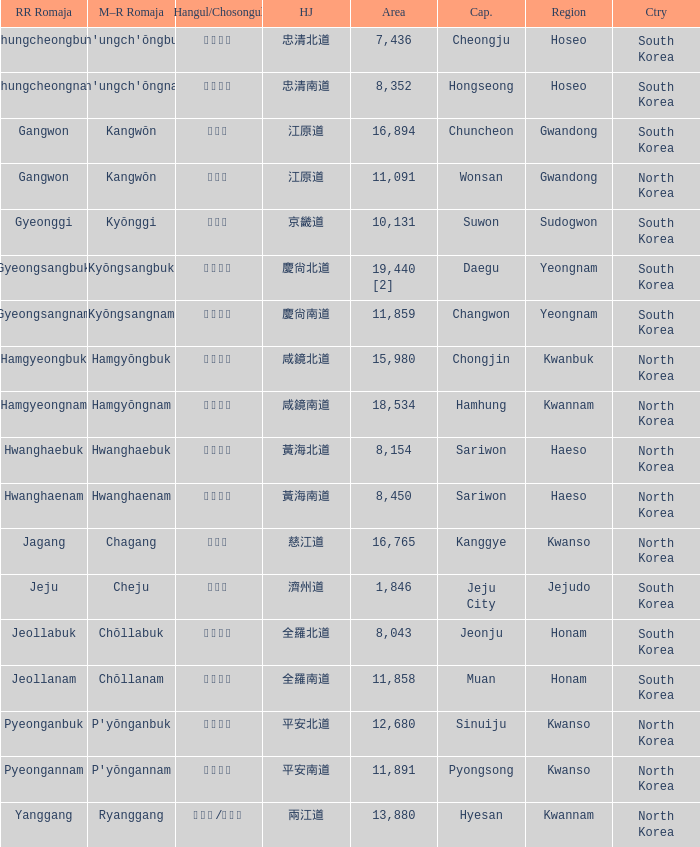Which capital has a hangul representation of 경상남도? Changwon. 